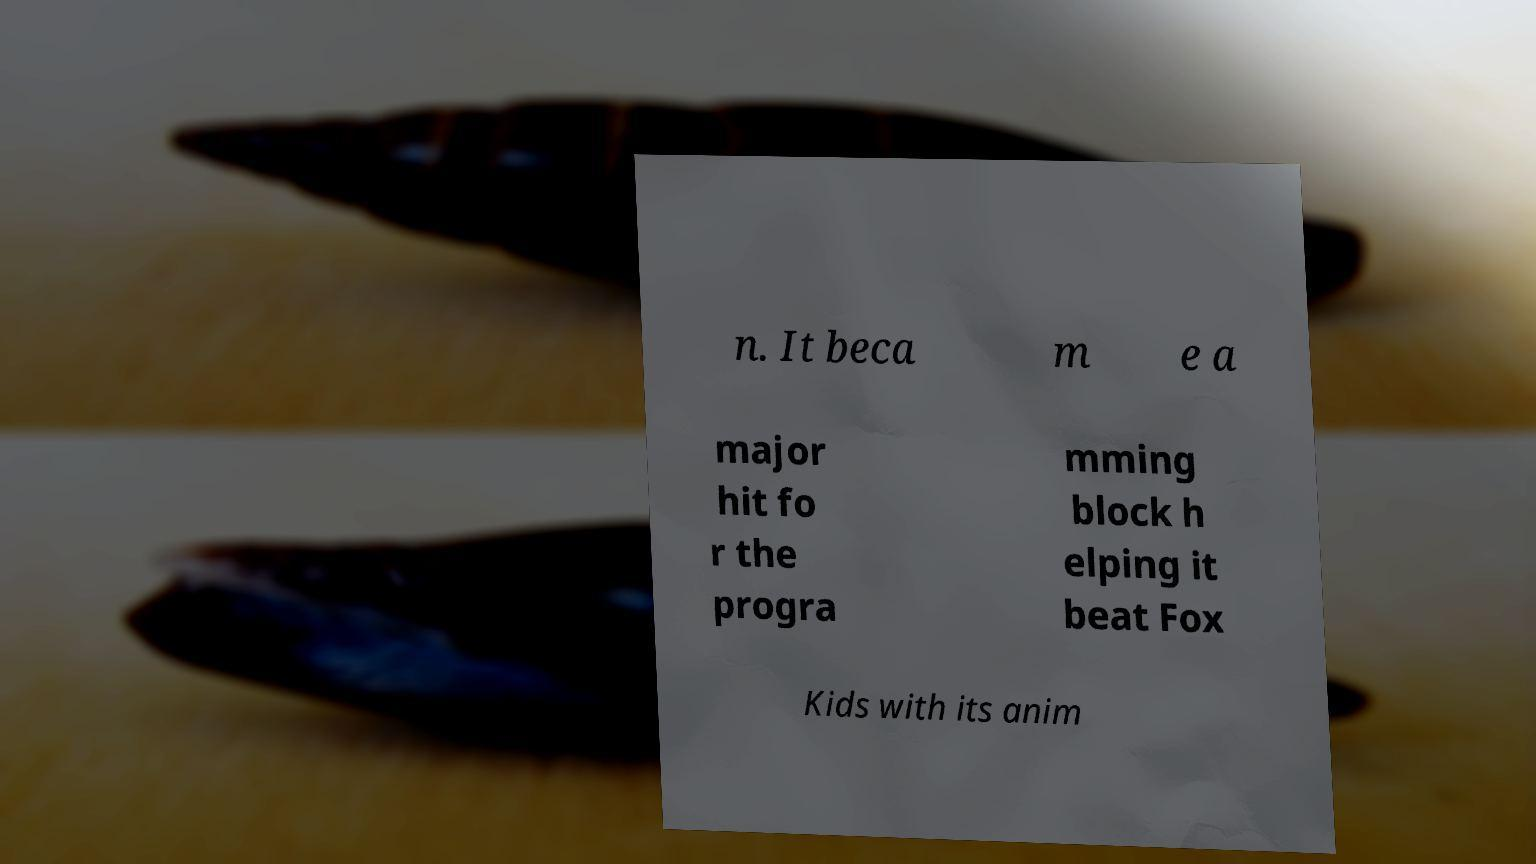I need the written content from this picture converted into text. Can you do that? n. It beca m e a major hit fo r the progra mming block h elping it beat Fox Kids with its anim 